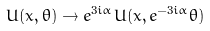<formula> <loc_0><loc_0><loc_500><loc_500>U ( x , \theta ) \rightarrow e ^ { 3 i \alpha } U ( x , e ^ { - 3 i \alpha } \theta )</formula> 